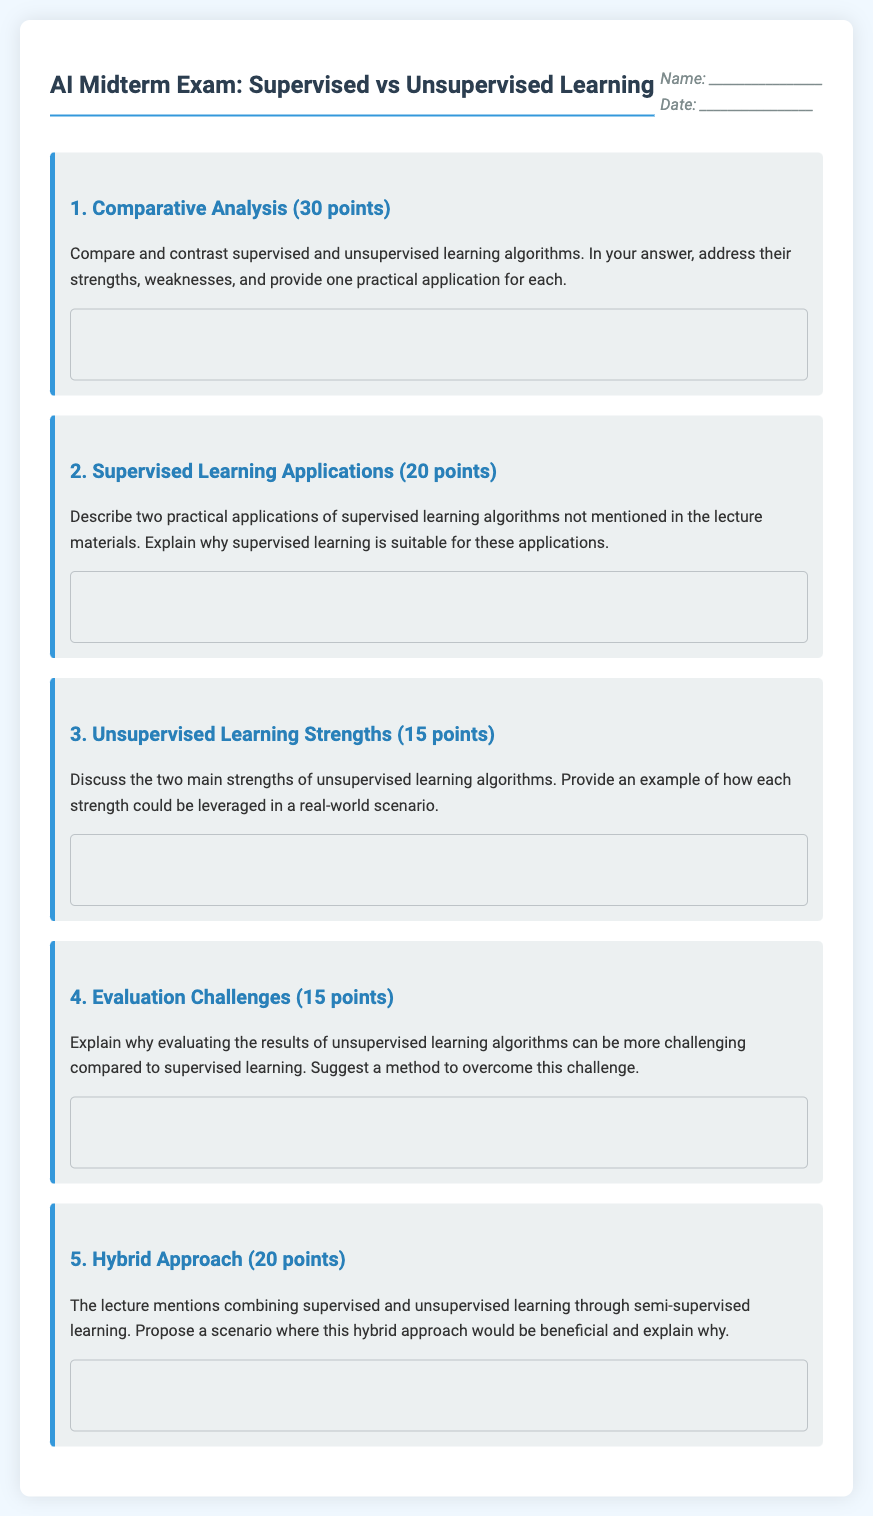What is the title of the exam? The title of the exam is displayed prominently at the top of the document, indicating the focus on supervised and unsupervised learning.
Answer: AI Midterm Exam: Supervised vs Unsupervised Learning How many points is the Comparative Analysis question worth? The number of points for each question is specified in parentheses next to the question, indicating its weight in the overall exam.
Answer: 30 points What is one strength of unsupervised learning algorithms? The question specifies discussing strengths of unsupervised learning algorithms, which requires recall from the document’s content.
Answer: (Answer will depend on the content of the student’s interpretation, typically they include discovering patterns or clustering.) What is one practical application for supervised learning? The instructions for the comparative analysis question ask for a practical application, which suggests answers related to supervised learning implementations.
Answer: (An example could be email spam detection, based on common knowledge.) How many questions are there in the exam? By counting the number of distinct question sections in the document, we can determine the total number of questions.
Answer: 5 What section discusses evaluation challenges in unsupervised learning? The organized layout specifies that evaluating unsupervised learning results is discussed in one of the question sections.
Answer: Question 4 How is the header formatted? The header is formatted with various visual elements, including titles, spacing, and alignment features that help to distinguish it from other sections.
Answer: Centered with a student info section What does the hybrid approach propose? The document introduces the concept of a hybrid approach combining supervised and unsupervised learning, leading to a particular question regarding its benefits.
Answer: Semi-supervised learning What color is used for headings in the document? The visual design of the document uses specific colors for headings, which can include comparisons of visual style elements throughout the text.
Answer: Various colors, mainly blue and teal 